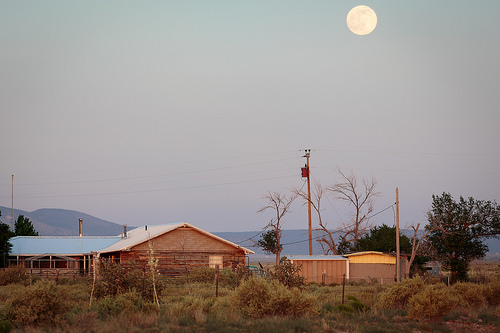<image>
Is there a sky behind the house? Yes. From this viewpoint, the sky is positioned behind the house, with the house partially or fully occluding the sky. Is there a mountain in front of the house? No. The mountain is not in front of the house. The spatial positioning shows a different relationship between these objects. 